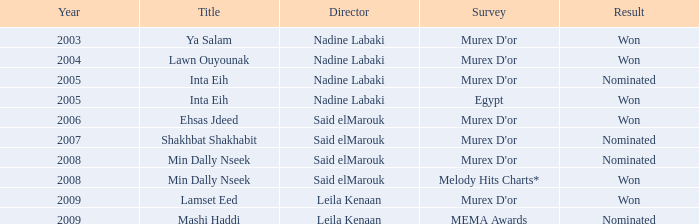Can you identify the survey with the title ehsas jdeed? Murex D'or. 